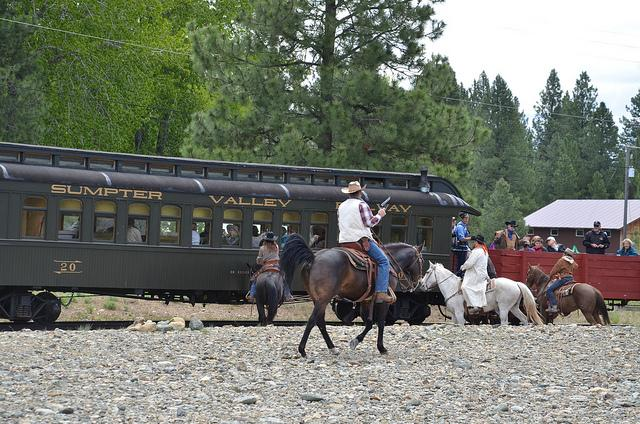What are the men on horses dressed as? cowboys 